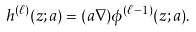<formula> <loc_0><loc_0><loc_500><loc_500>h ^ { ( \ell ) } ( z ; a ) = ( a \nabla ) \phi ^ { ( \ell - 1 ) } ( z ; a ) .</formula> 